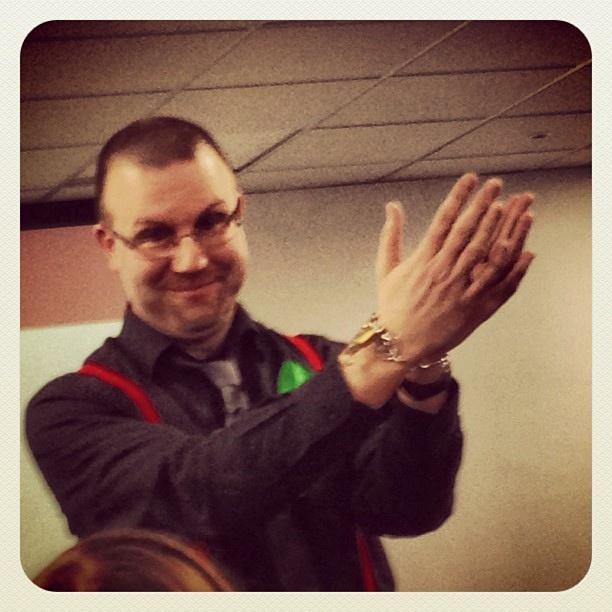Describe the objects in this image and their specific colors. I can see people in ivory, black, maroon, brown, and tan tones and tie in ivory, brown, maroon, gray, and black tones in this image. 